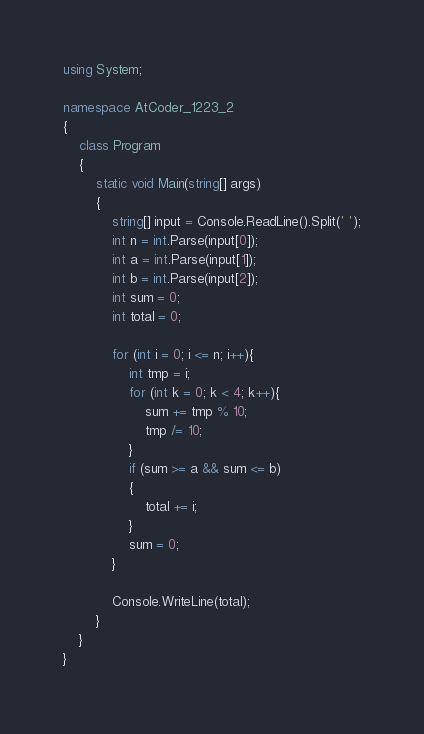<code> <loc_0><loc_0><loc_500><loc_500><_C#_>using System;

namespace AtCoder_1223_2
{
    class Program
    {
        static void Main(string[] args)
        {
            string[] input = Console.ReadLine().Split(' ');
            int n = int.Parse(input[0]);
            int a = int.Parse(input[1]);
            int b = int.Parse(input[2]);
            int sum = 0;
            int total = 0;

            for (int i = 0; i <= n; i++){
                int tmp = i;
                for (int k = 0; k < 4; k++){
                    sum += tmp % 10;
                    tmp /= 10;
                }
                if (sum >= a && sum <= b)
                {
                    total += i;
                }
                sum = 0;
            }

            Console.WriteLine(total);
        }
    }
}</code> 